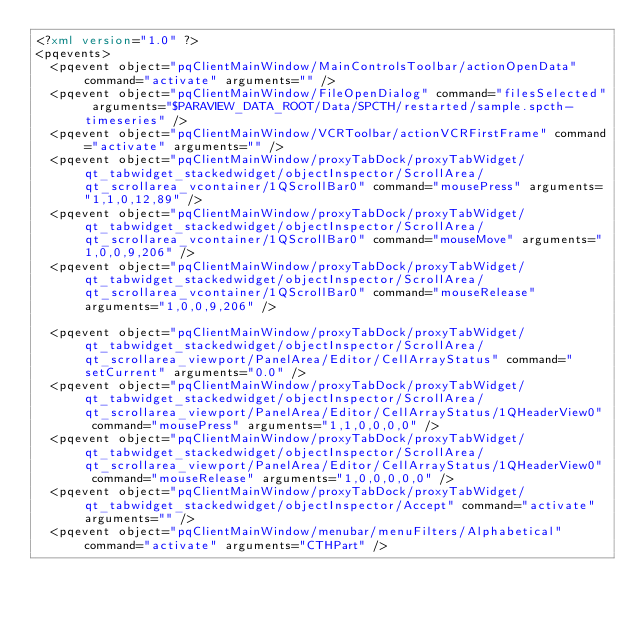Convert code to text. <code><loc_0><loc_0><loc_500><loc_500><_XML_><?xml version="1.0" ?>
<pqevents>
  <pqevent object="pqClientMainWindow/MainControlsToolbar/actionOpenData" command="activate" arguments="" />
  <pqevent object="pqClientMainWindow/FileOpenDialog" command="filesSelected" arguments="$PARAVIEW_DATA_ROOT/Data/SPCTH/restarted/sample.spcth-timeseries" />
  <pqevent object="pqClientMainWindow/VCRToolbar/actionVCRFirstFrame" command="activate" arguments="" />  
  <pqevent object="pqClientMainWindow/proxyTabDock/proxyTabWidget/qt_tabwidget_stackedwidget/objectInspector/ScrollArea/qt_scrollarea_vcontainer/1QScrollBar0" command="mousePress" arguments="1,1,0,12,89" />
  <pqevent object="pqClientMainWindow/proxyTabDock/proxyTabWidget/qt_tabwidget_stackedwidget/objectInspector/ScrollArea/qt_scrollarea_vcontainer/1QScrollBar0" command="mouseMove" arguments="1,0,0,9,206" />
  <pqevent object="pqClientMainWindow/proxyTabDock/proxyTabWidget/qt_tabwidget_stackedwidget/objectInspector/ScrollArea/qt_scrollarea_vcontainer/1QScrollBar0" command="mouseRelease" arguments="1,0,0,9,206" />

  <pqevent object="pqClientMainWindow/proxyTabDock/proxyTabWidget/qt_tabwidget_stackedwidget/objectInspector/ScrollArea/qt_scrollarea_viewport/PanelArea/Editor/CellArrayStatus" command="setCurrent" arguments="0.0" />
  <pqevent object="pqClientMainWindow/proxyTabDock/proxyTabWidget/qt_tabwidget_stackedwidget/objectInspector/ScrollArea/qt_scrollarea_viewport/PanelArea/Editor/CellArrayStatus/1QHeaderView0" command="mousePress" arguments="1,1,0,0,0,0" />
  <pqevent object="pqClientMainWindow/proxyTabDock/proxyTabWidget/qt_tabwidget_stackedwidget/objectInspector/ScrollArea/qt_scrollarea_viewport/PanelArea/Editor/CellArrayStatus/1QHeaderView0" command="mouseRelease" arguments="1,0,0,0,0,0" />
  <pqevent object="pqClientMainWindow/proxyTabDock/proxyTabWidget/qt_tabwidget_stackedwidget/objectInspector/Accept" command="activate" arguments="" />
  <pqevent object="pqClientMainWindow/menubar/menuFilters/Alphabetical" command="activate" arguments="CTHPart" /></code> 